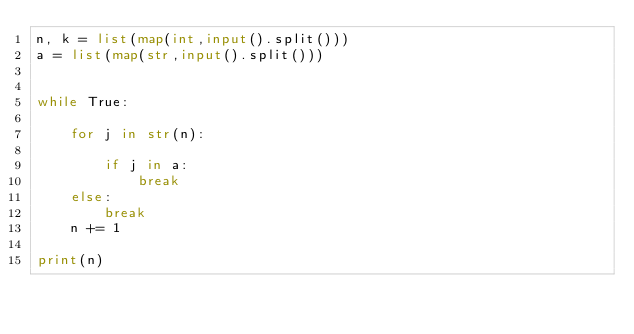<code> <loc_0><loc_0><loc_500><loc_500><_Python_>n, k = list(map(int,input().split()))
a = list(map(str,input().split()))


while True:
    
    for j in str(n):
        
        if j in a:
            break
    else:
        break
    n += 1        
    
print(n)</code> 